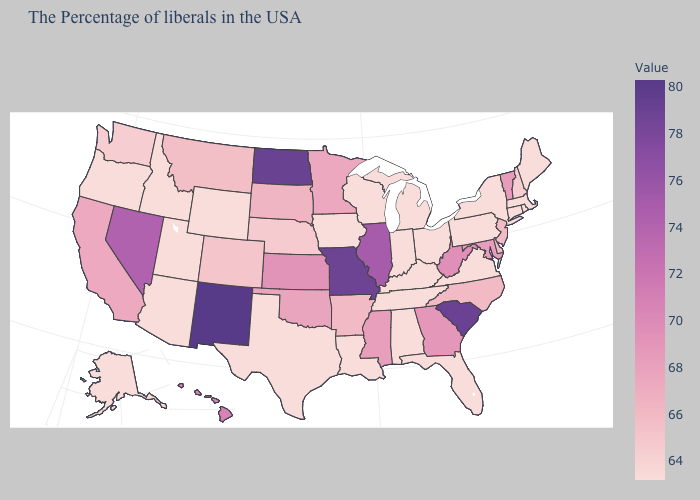Does Mississippi have a higher value than South Carolina?
Be succinct. No. Which states hav the highest value in the West?
Concise answer only. New Mexico. Which states have the lowest value in the South?
Quick response, please. Virginia, Florida, Kentucky, Alabama, Tennessee, Louisiana, Texas. Among the states that border Arkansas , which have the highest value?
Short answer required. Missouri. Is the legend a continuous bar?
Short answer required. Yes. Which states have the highest value in the USA?
Short answer required. New Mexico. Is the legend a continuous bar?
Quick response, please. Yes. Does Maine have the lowest value in the Northeast?
Be succinct. Yes. Among the states that border Vermont , which have the highest value?
Answer briefly. New Hampshire. Which states have the highest value in the USA?
Keep it brief. New Mexico. Among the states that border Delaware , does Maryland have the highest value?
Be succinct. Yes. Does Indiana have the lowest value in the USA?
Be succinct. Yes. 